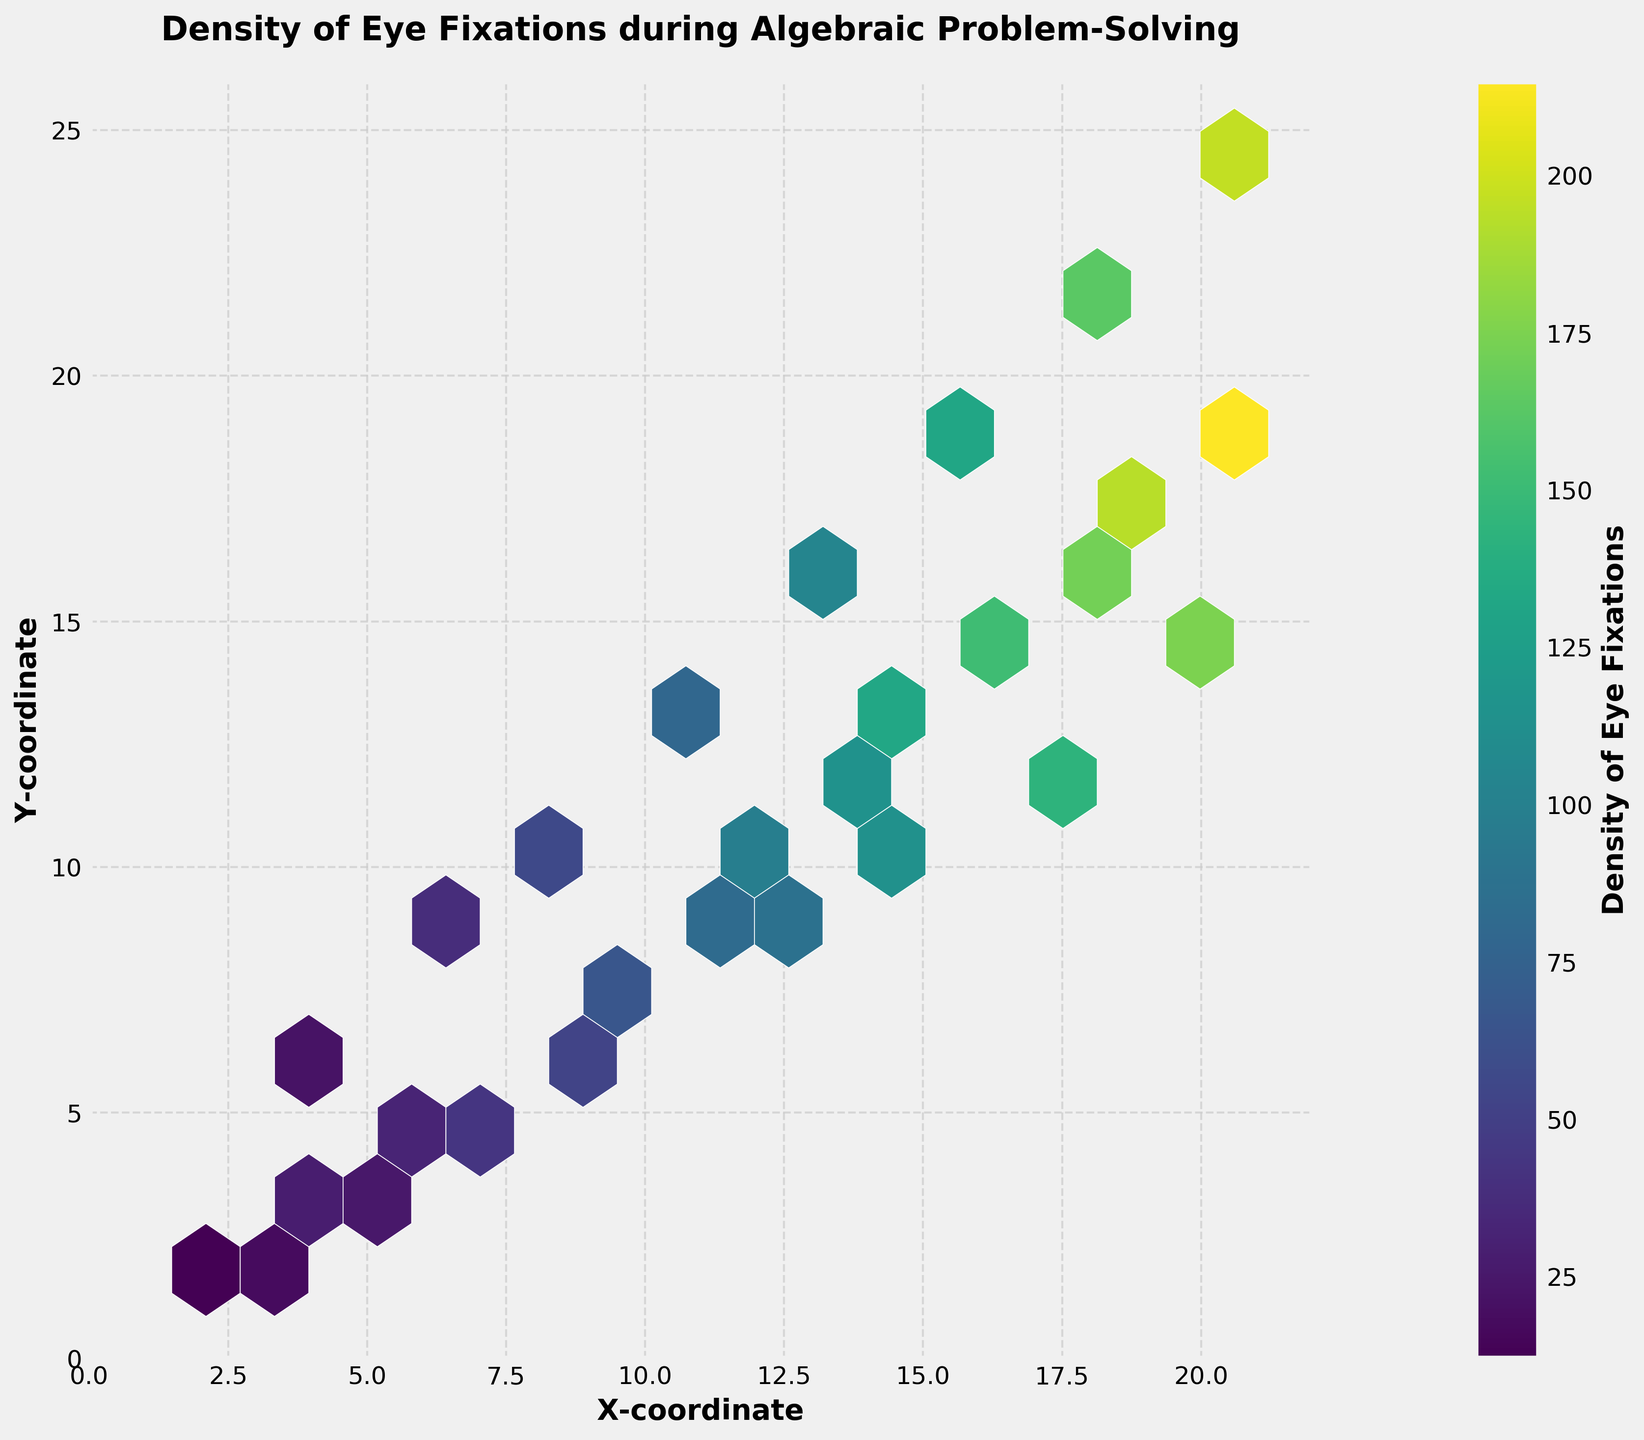What is the title of the plot? The title of the plot is typically displayed at the top of the figure. In this case, the title reads "Density of Eye Fixations during Algebraic Problem-Solving".
Answer: Density of Eye Fixations during Algebraic Problem-Solving What are the labels of the x-axis and y-axis? The labels for both axes usually appear along the axes. For this plot, the x-axis is labeled "X-coordinate" and the y-axis is labeled "Y-coordinate".
Answer: X-coordinate; Y-coordinate Which area in the plot has the highest density of eye fixations? In a hexbin plot, the density is often indicated using colors. The area with the darkest color or highest number in the colorbar represents the highest density. From the colorbar and denser hexagons, the highest density corresponds to coordinates around (20, 18) with a density of 215.
Answer: Around (20, 18) What is the range of densities shown on the colorbar? The colorbar on the right side of the plot displays the range of densities. It starts from the minimum value around 12 and goes up to a maximum value of 215.
Answer: 12 to 215 Do eye fixations tend to be denser at higher or lower y-coordinates? By observing the hexbin plot, denser regions often appear at higher y-coordinates. This can be inferred from the concentration of denser hexagons towards the top of the plot.
Answer: Higher y-coordinates How does the density of eye fixation change from (4, 2) to (12, 10)? Observing the gradient of color change from these coordinates: At (4, 2), the density is lower, and it increases steadily as we move towards (12, 10). This is visible by the gradual darkening of hexagons.
Answer: It increases Which pair of coordinates has a similar density to (9, 8)? Compare colors or densities around similar coordinates. At (9, 8), the density is around 67. From the plot, coordinates around (12, 10) have a similar color and density.
Answer: (12, 10) What does a denser cluster in a hexbin plot indicate? In hexbin plots, denser clusters indicate a higher concentration of data points in those areas. For this figure, it would mean more eye fixations at certain coordinates, suggesting areas of greater cognitive focus during the task.
Answer: Higher concentration of eye fixations Which direction shows a higher density change, horizontal or vertical? By comparing changes in density along both axes: Vertically, there is a significant gradient (densities change more clearly from top to bottom) compared to horizontally.
Answer: Vertical Between x-coordinates 10 and 15, how does the eye fixation density trend? Observe the density changes between these coordinates across the x-axis. It shows an increasing trend as one moves from x=10 to x=15, indicated by the darkening of hexagons in this range.
Answer: It increases 